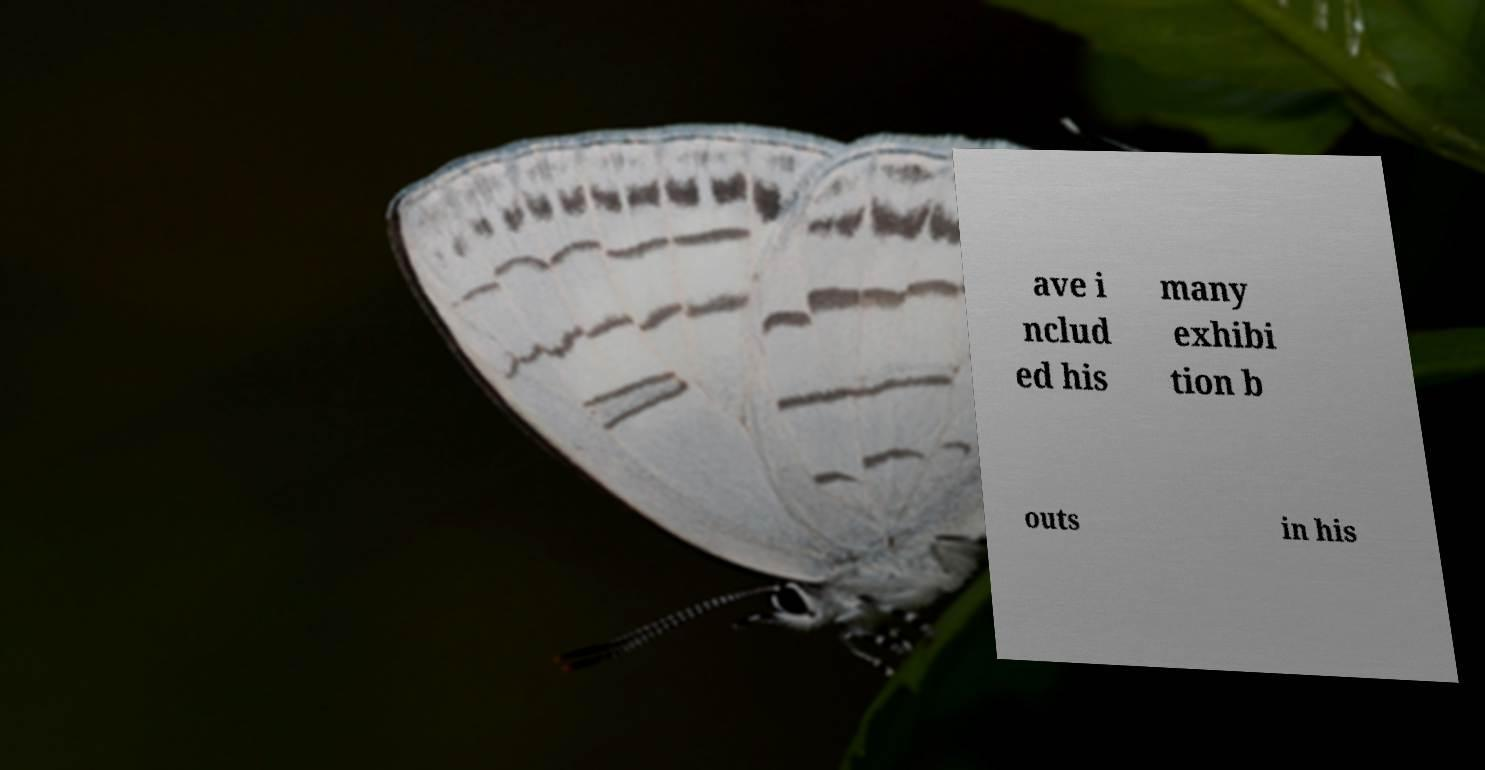Please identify and transcribe the text found in this image. ave i nclud ed his many exhibi tion b outs in his 